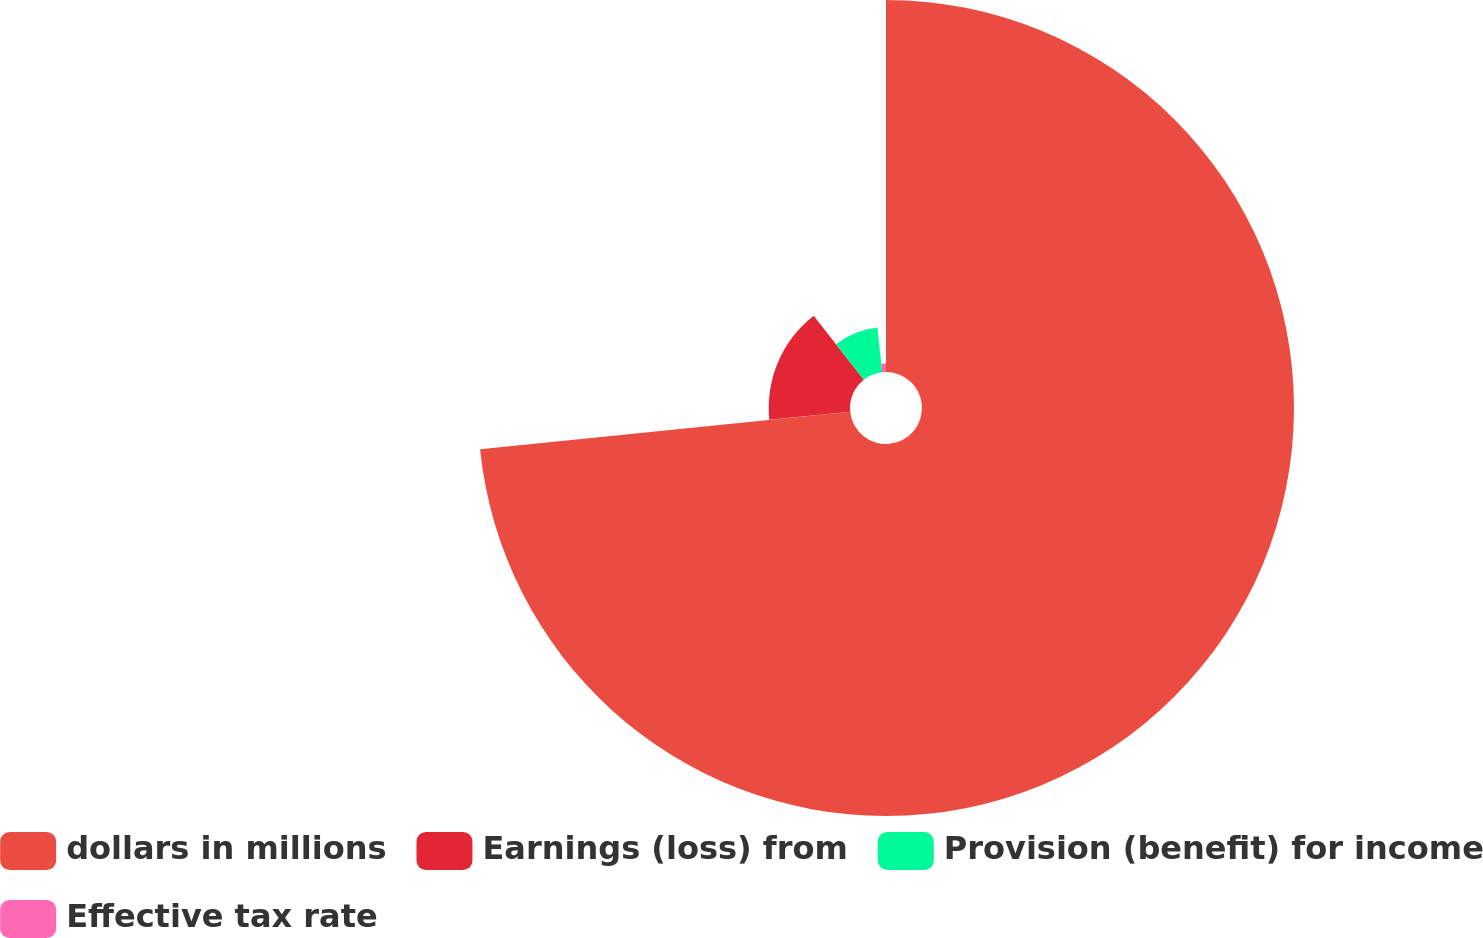<chart> <loc_0><loc_0><loc_500><loc_500><pie_chart><fcel>dollars in millions<fcel>Earnings (loss) from<fcel>Provision (benefit) for income<fcel>Effective tax rate<nl><fcel>73.39%<fcel>16.04%<fcel>8.87%<fcel>1.7%<nl></chart> 